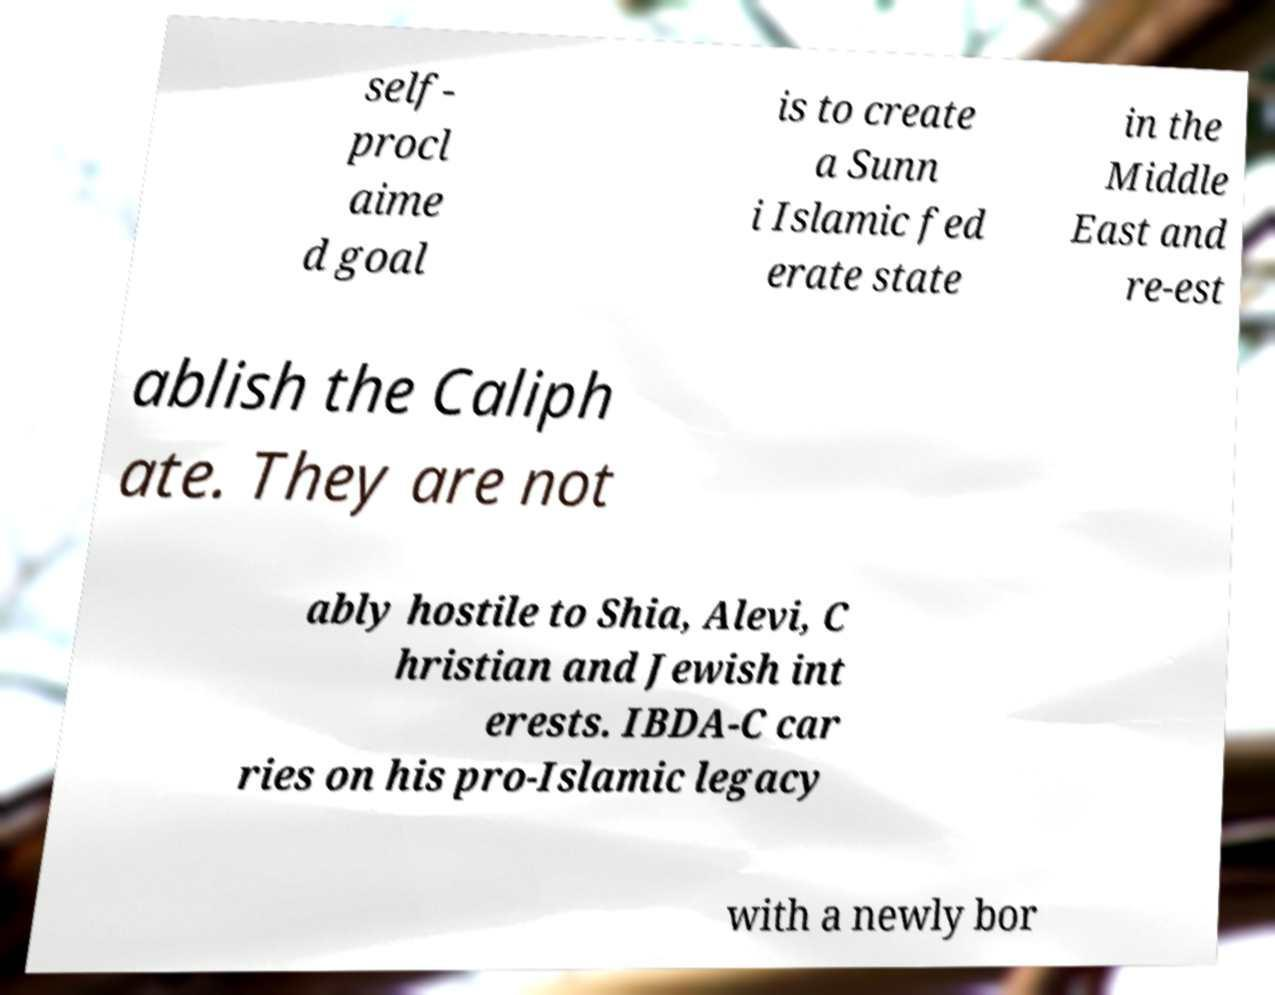Could you assist in decoding the text presented in this image and type it out clearly? self- procl aime d goal is to create a Sunn i Islamic fed erate state in the Middle East and re-est ablish the Caliph ate. They are not ably hostile to Shia, Alevi, C hristian and Jewish int erests. IBDA-C car ries on his pro-Islamic legacy with a newly bor 